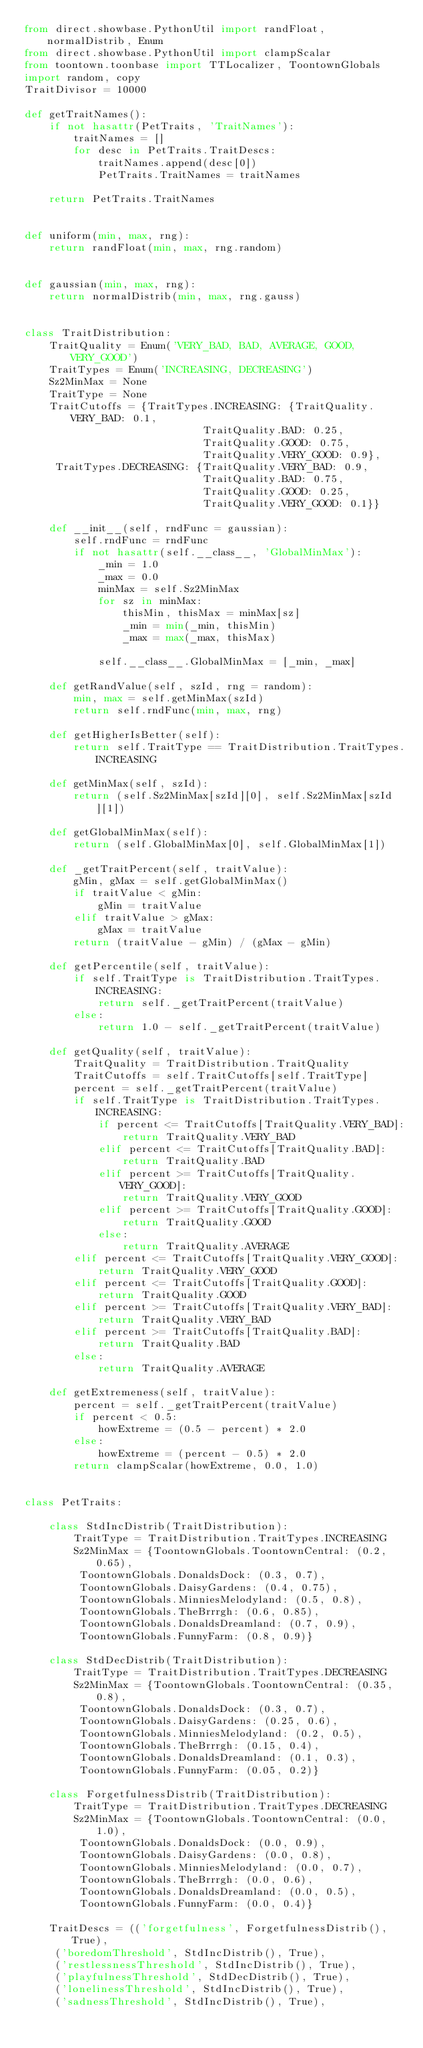<code> <loc_0><loc_0><loc_500><loc_500><_Python_>from direct.showbase.PythonUtil import randFloat, normalDistrib, Enum
from direct.showbase.PythonUtil import clampScalar
from toontown.toonbase import TTLocalizer, ToontownGlobals
import random, copy
TraitDivisor = 10000

def getTraitNames():
    if not hasattr(PetTraits, 'TraitNames'):
        traitNames = []
        for desc in PetTraits.TraitDescs:
            traitNames.append(desc[0])
            PetTraits.TraitNames = traitNames

    return PetTraits.TraitNames


def uniform(min, max, rng):
    return randFloat(min, max, rng.random)


def gaussian(min, max, rng):
    return normalDistrib(min, max, rng.gauss)


class TraitDistribution:
    TraitQuality = Enum('VERY_BAD, BAD, AVERAGE, GOOD, VERY_GOOD')
    TraitTypes = Enum('INCREASING, DECREASING')
    Sz2MinMax = None
    TraitType = None
    TraitCutoffs = {TraitTypes.INCREASING: {TraitQuality.VERY_BAD: 0.1,
                             TraitQuality.BAD: 0.25,
                             TraitQuality.GOOD: 0.75,
                             TraitQuality.VERY_GOOD: 0.9},
     TraitTypes.DECREASING: {TraitQuality.VERY_BAD: 0.9,
                             TraitQuality.BAD: 0.75,
                             TraitQuality.GOOD: 0.25,
                             TraitQuality.VERY_GOOD: 0.1}}

    def __init__(self, rndFunc = gaussian):
        self.rndFunc = rndFunc
        if not hasattr(self.__class__, 'GlobalMinMax'):
            _min = 1.0
            _max = 0.0
            minMax = self.Sz2MinMax
            for sz in minMax:
                thisMin, thisMax = minMax[sz]
                _min = min(_min, thisMin)
                _max = max(_max, thisMax)

            self.__class__.GlobalMinMax = [_min, _max]

    def getRandValue(self, szId, rng = random):
        min, max = self.getMinMax(szId)
        return self.rndFunc(min, max, rng)

    def getHigherIsBetter(self):
        return self.TraitType == TraitDistribution.TraitTypes.INCREASING

    def getMinMax(self, szId):
        return (self.Sz2MinMax[szId][0], self.Sz2MinMax[szId][1])

    def getGlobalMinMax(self):
        return (self.GlobalMinMax[0], self.GlobalMinMax[1])

    def _getTraitPercent(self, traitValue):
        gMin, gMax = self.getGlobalMinMax()
        if traitValue < gMin:
            gMin = traitValue
        elif traitValue > gMax:
            gMax = traitValue
        return (traitValue - gMin) / (gMax - gMin)

    def getPercentile(self, traitValue):
        if self.TraitType is TraitDistribution.TraitTypes.INCREASING:
            return self._getTraitPercent(traitValue)
        else:
            return 1.0 - self._getTraitPercent(traitValue)

    def getQuality(self, traitValue):
        TraitQuality = TraitDistribution.TraitQuality
        TraitCutoffs = self.TraitCutoffs[self.TraitType]
        percent = self._getTraitPercent(traitValue)
        if self.TraitType is TraitDistribution.TraitTypes.INCREASING:
            if percent <= TraitCutoffs[TraitQuality.VERY_BAD]:
                return TraitQuality.VERY_BAD
            elif percent <= TraitCutoffs[TraitQuality.BAD]:
                return TraitQuality.BAD
            elif percent >= TraitCutoffs[TraitQuality.VERY_GOOD]:
                return TraitQuality.VERY_GOOD
            elif percent >= TraitCutoffs[TraitQuality.GOOD]:
                return TraitQuality.GOOD
            else:
                return TraitQuality.AVERAGE
        elif percent <= TraitCutoffs[TraitQuality.VERY_GOOD]:
            return TraitQuality.VERY_GOOD
        elif percent <= TraitCutoffs[TraitQuality.GOOD]:
            return TraitQuality.GOOD
        elif percent >= TraitCutoffs[TraitQuality.VERY_BAD]:
            return TraitQuality.VERY_BAD
        elif percent >= TraitCutoffs[TraitQuality.BAD]:
            return TraitQuality.BAD
        else:
            return TraitQuality.AVERAGE

    def getExtremeness(self, traitValue):
        percent = self._getTraitPercent(traitValue)
        if percent < 0.5:
            howExtreme = (0.5 - percent) * 2.0
        else:
            howExtreme = (percent - 0.5) * 2.0
        return clampScalar(howExtreme, 0.0, 1.0)


class PetTraits:

    class StdIncDistrib(TraitDistribution):
        TraitType = TraitDistribution.TraitTypes.INCREASING
        Sz2MinMax = {ToontownGlobals.ToontownCentral: (0.2, 0.65),
         ToontownGlobals.DonaldsDock: (0.3, 0.7),
         ToontownGlobals.DaisyGardens: (0.4, 0.75),
         ToontownGlobals.MinniesMelodyland: (0.5, 0.8),
         ToontownGlobals.TheBrrrgh: (0.6, 0.85),
         ToontownGlobals.DonaldsDreamland: (0.7, 0.9),
         ToontownGlobals.FunnyFarm: (0.8, 0.9)}

    class StdDecDistrib(TraitDistribution):
        TraitType = TraitDistribution.TraitTypes.DECREASING
        Sz2MinMax = {ToontownGlobals.ToontownCentral: (0.35, 0.8),
         ToontownGlobals.DonaldsDock: (0.3, 0.7),
         ToontownGlobals.DaisyGardens: (0.25, 0.6),
         ToontownGlobals.MinniesMelodyland: (0.2, 0.5),
         ToontownGlobals.TheBrrrgh: (0.15, 0.4),
         ToontownGlobals.DonaldsDreamland: (0.1, 0.3),
         ToontownGlobals.FunnyFarm: (0.05, 0.2)}

    class ForgetfulnessDistrib(TraitDistribution):
        TraitType = TraitDistribution.TraitTypes.DECREASING
        Sz2MinMax = {ToontownGlobals.ToontownCentral: (0.0, 1.0),
         ToontownGlobals.DonaldsDock: (0.0, 0.9),
         ToontownGlobals.DaisyGardens: (0.0, 0.8),
         ToontownGlobals.MinniesMelodyland: (0.0, 0.7),
         ToontownGlobals.TheBrrrgh: (0.0, 0.6),
         ToontownGlobals.DonaldsDreamland: (0.0, 0.5),
         ToontownGlobals.FunnyFarm: (0.0, 0.4)}

    TraitDescs = (('forgetfulness', ForgetfulnessDistrib(), True),
     ('boredomThreshold', StdIncDistrib(), True),
     ('restlessnessThreshold', StdIncDistrib(), True),
     ('playfulnessThreshold', StdDecDistrib(), True),
     ('lonelinessThreshold', StdIncDistrib(), True),
     ('sadnessThreshold', StdIncDistrib(), True),</code> 